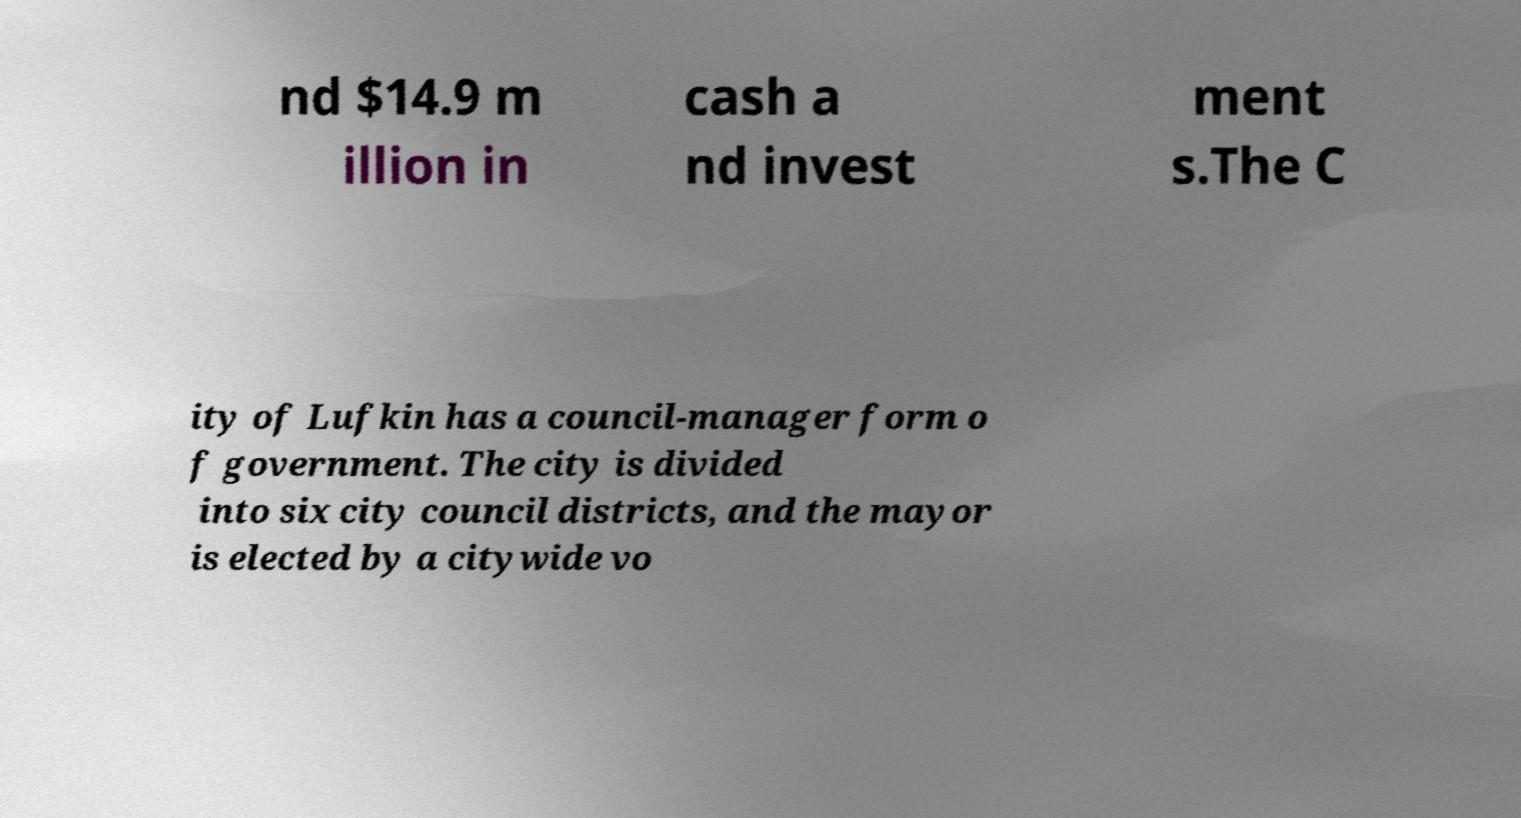Please read and relay the text visible in this image. What does it say? nd $14.9 m illion in cash a nd invest ment s.The C ity of Lufkin has a council-manager form o f government. The city is divided into six city council districts, and the mayor is elected by a citywide vo 